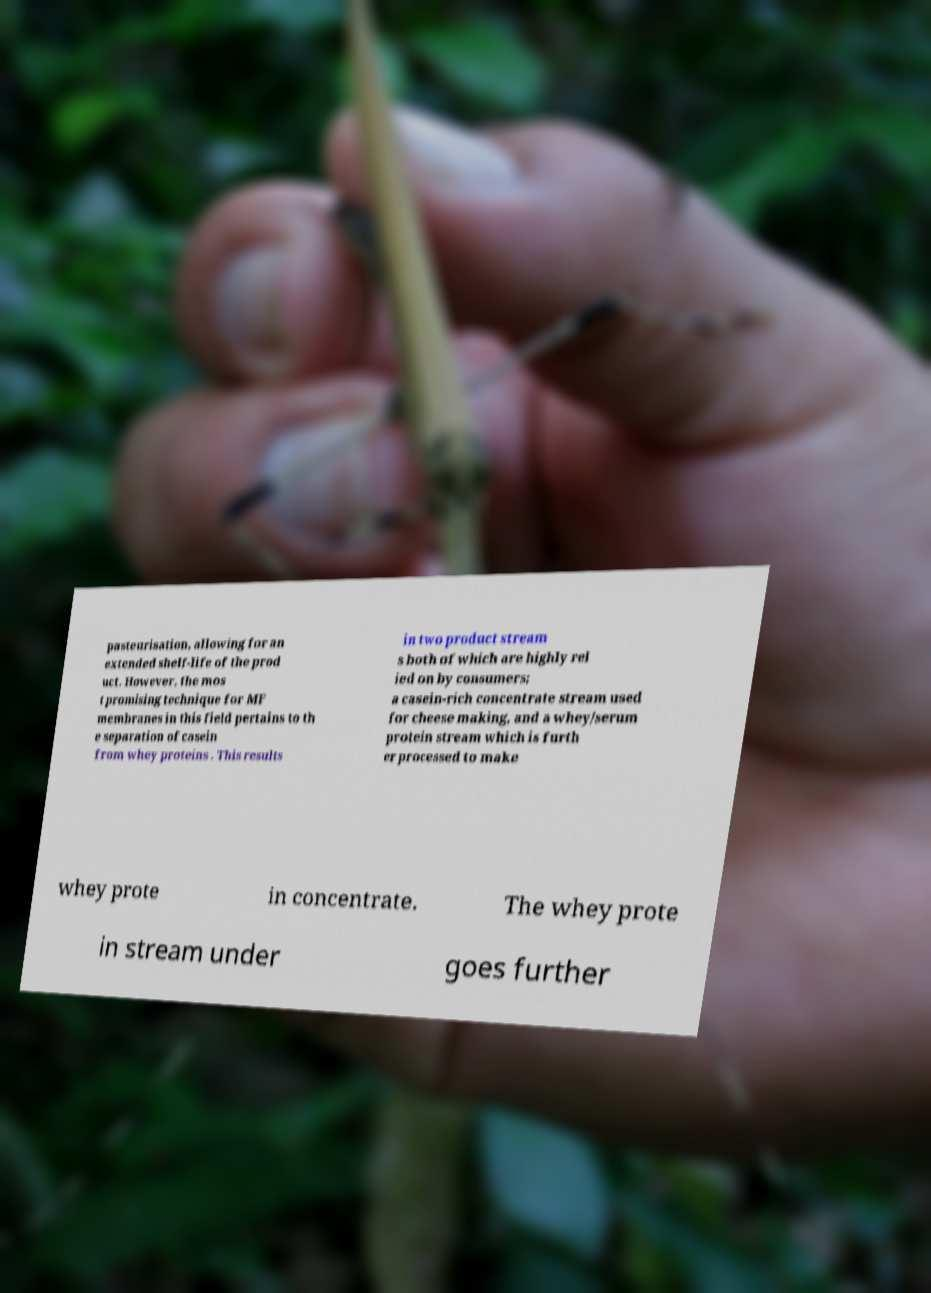Can you accurately transcribe the text from the provided image for me? pasteurisation, allowing for an extended shelf-life of the prod uct. However, the mos t promising technique for MF membranes in this field pertains to th e separation of casein from whey proteins . This results in two product stream s both of which are highly rel ied on by consumers; a casein-rich concentrate stream used for cheese making, and a whey/serum protein stream which is furth er processed to make whey prote in concentrate. The whey prote in stream under goes further 